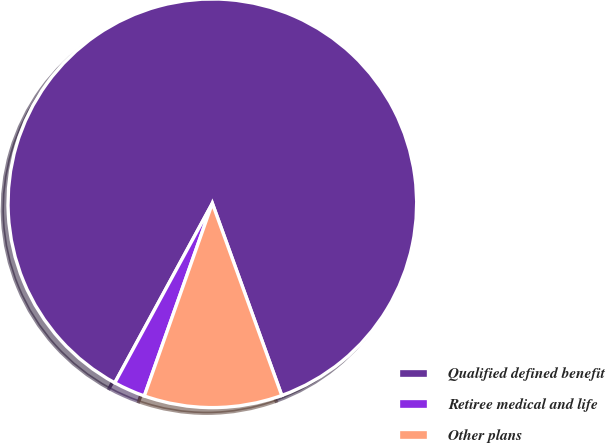Convert chart to OTSL. <chart><loc_0><loc_0><loc_500><loc_500><pie_chart><fcel>Qualified defined benefit<fcel>Retiree medical and life<fcel>Other plans<nl><fcel>86.56%<fcel>2.52%<fcel>10.92%<nl></chart> 